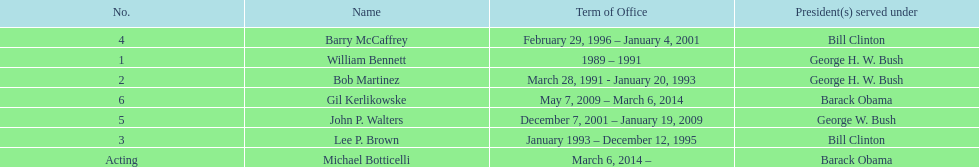What were the total number of years bob martinez served in office? 2. 